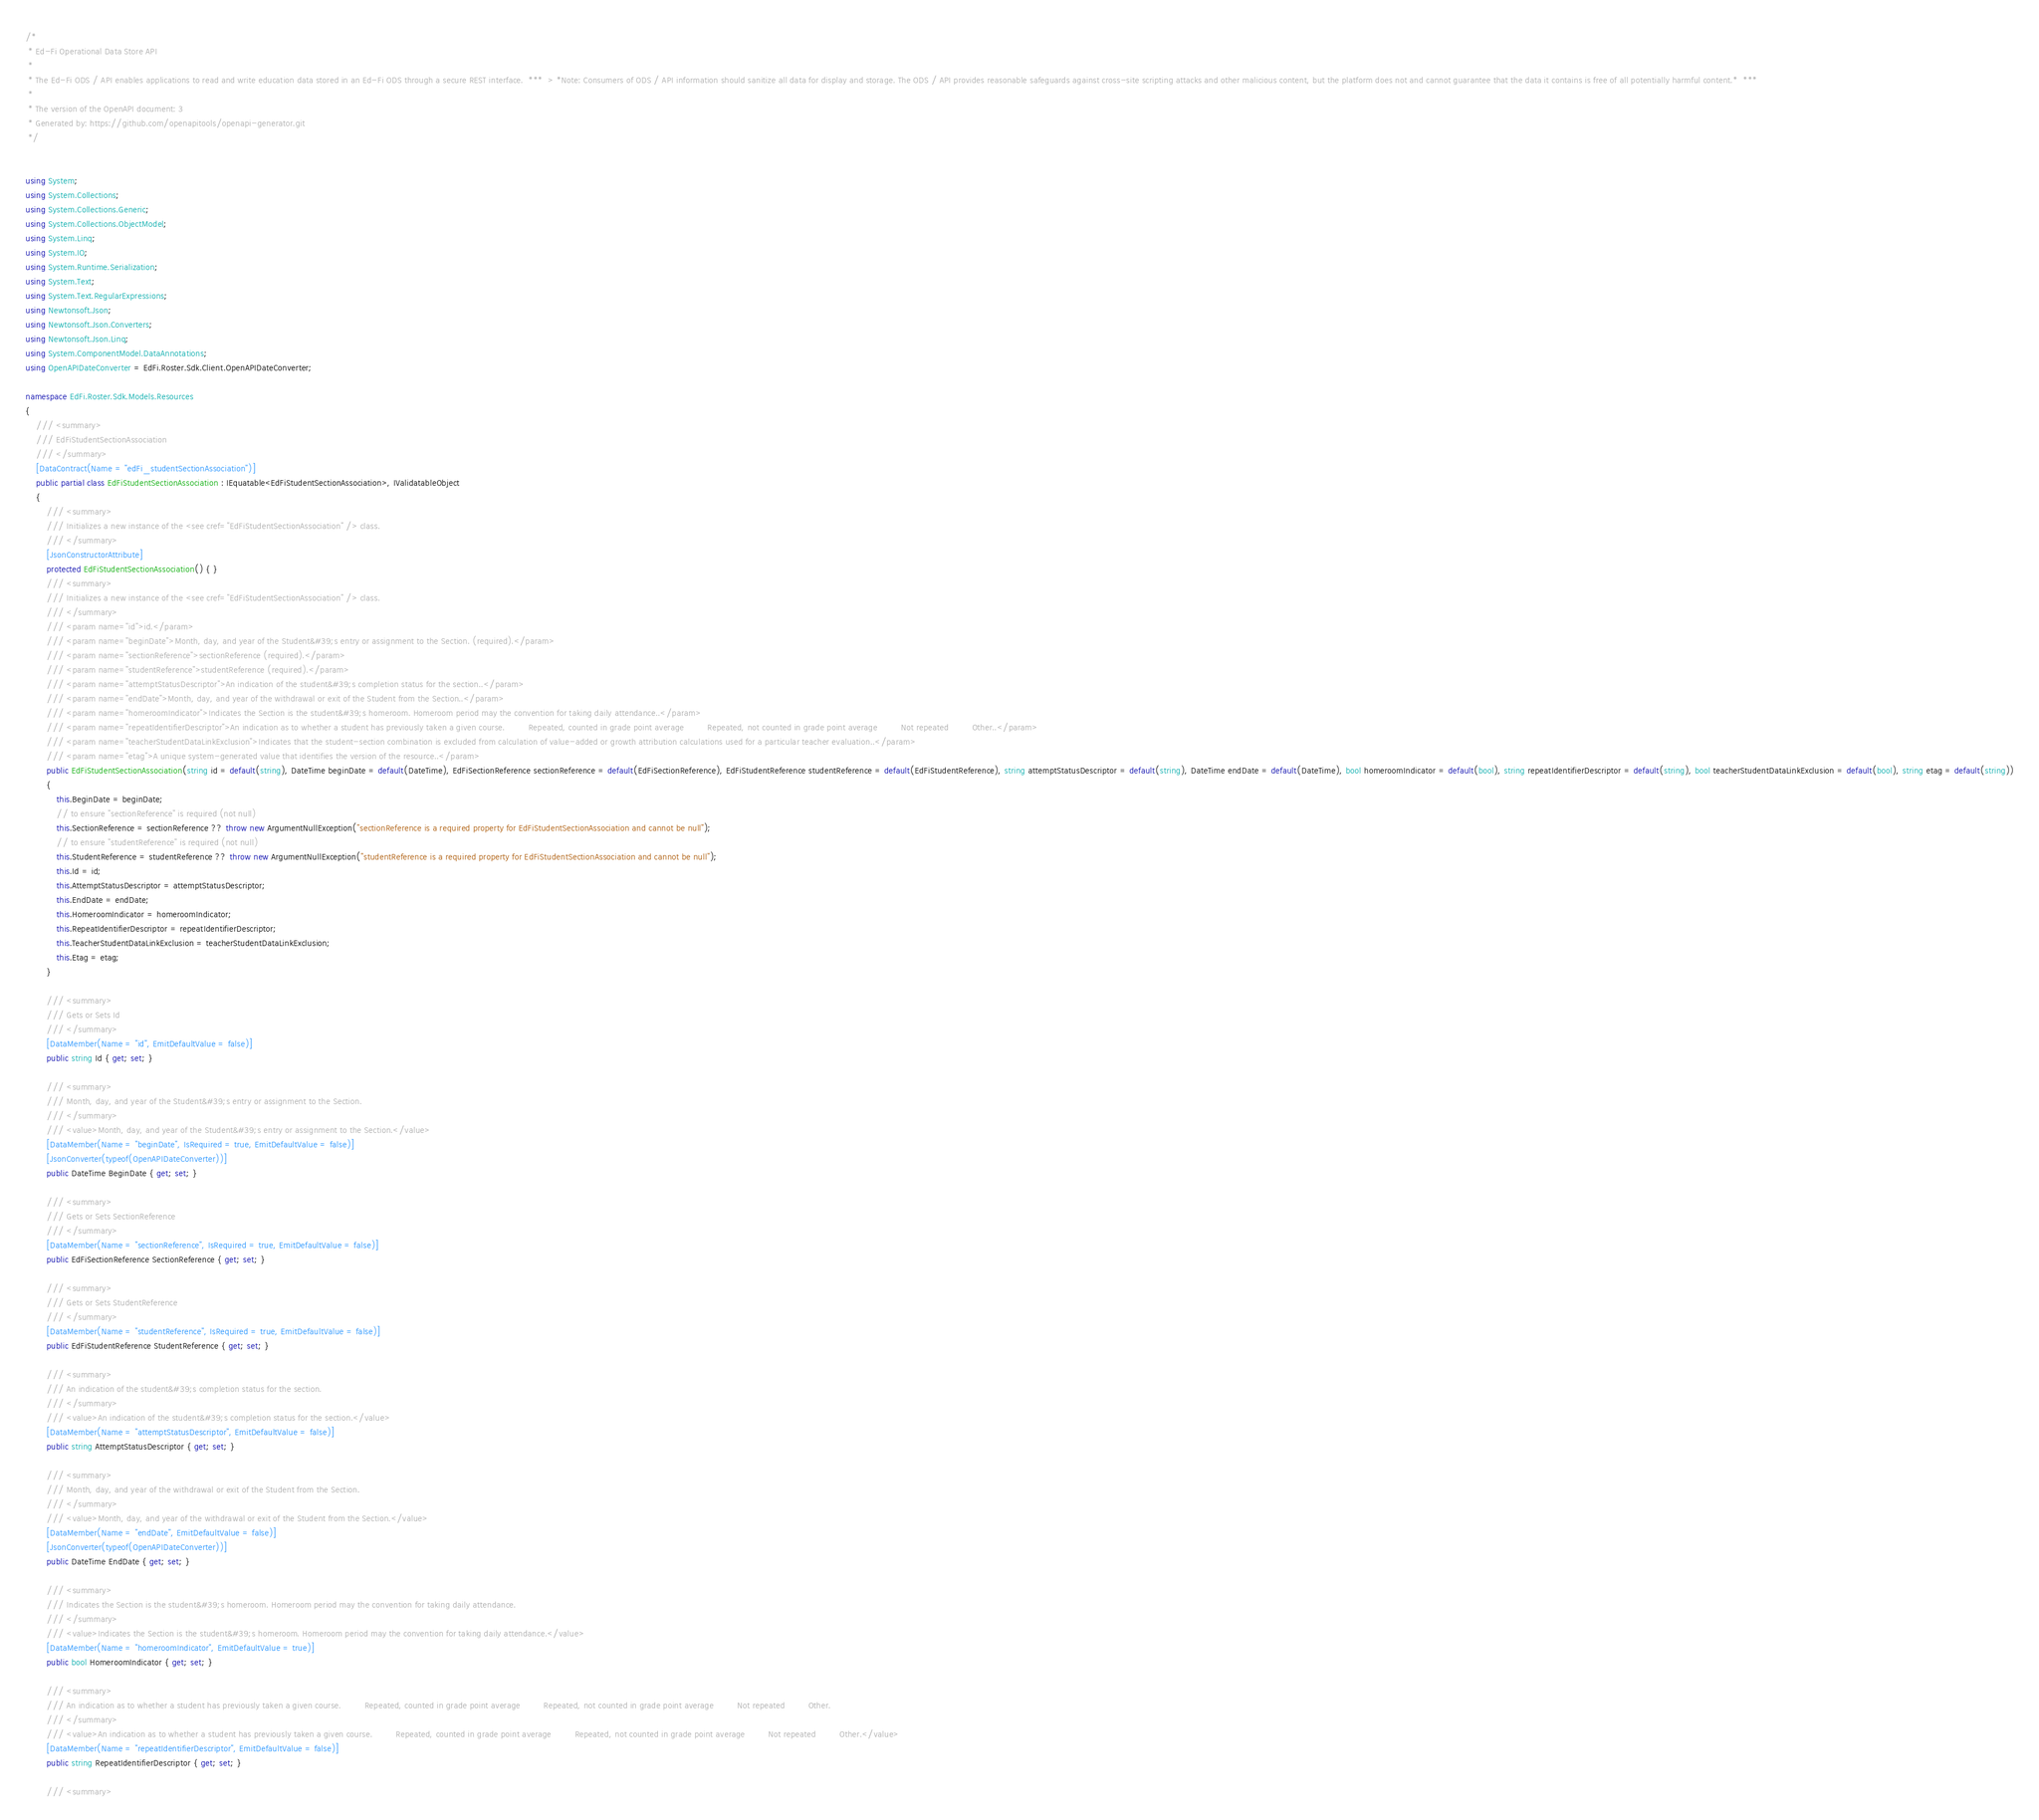<code> <loc_0><loc_0><loc_500><loc_500><_C#_>/*
 * Ed-Fi Operational Data Store API
 *
 * The Ed-Fi ODS / API enables applications to read and write education data stored in an Ed-Fi ODS through a secure REST interface.  ***  > *Note: Consumers of ODS / API information should sanitize all data for display and storage. The ODS / API provides reasonable safeguards against cross-site scripting attacks and other malicious content, but the platform does not and cannot guarantee that the data it contains is free of all potentially harmful content.*  *** 
 *
 * The version of the OpenAPI document: 3
 * Generated by: https://github.com/openapitools/openapi-generator.git
 */


using System;
using System.Collections;
using System.Collections.Generic;
using System.Collections.ObjectModel;
using System.Linq;
using System.IO;
using System.Runtime.Serialization;
using System.Text;
using System.Text.RegularExpressions;
using Newtonsoft.Json;
using Newtonsoft.Json.Converters;
using Newtonsoft.Json.Linq;
using System.ComponentModel.DataAnnotations;
using OpenAPIDateConverter = EdFi.Roster.Sdk.Client.OpenAPIDateConverter;

namespace EdFi.Roster.Sdk.Models.Resources
{
    /// <summary>
    /// EdFiStudentSectionAssociation
    /// </summary>
    [DataContract(Name = "edFi_studentSectionAssociation")]
    public partial class EdFiStudentSectionAssociation : IEquatable<EdFiStudentSectionAssociation>, IValidatableObject
    {
        /// <summary>
        /// Initializes a new instance of the <see cref="EdFiStudentSectionAssociation" /> class.
        /// </summary>
        [JsonConstructorAttribute]
        protected EdFiStudentSectionAssociation() { }
        /// <summary>
        /// Initializes a new instance of the <see cref="EdFiStudentSectionAssociation" /> class.
        /// </summary>
        /// <param name="id">id.</param>
        /// <param name="beginDate">Month, day, and year of the Student&#39;s entry or assignment to the Section. (required).</param>
        /// <param name="sectionReference">sectionReference (required).</param>
        /// <param name="studentReference">studentReference (required).</param>
        /// <param name="attemptStatusDescriptor">An indication of the student&#39;s completion status for the section..</param>
        /// <param name="endDate">Month, day, and year of the withdrawal or exit of the Student from the Section..</param>
        /// <param name="homeroomIndicator">Indicates the Section is the student&#39;s homeroom. Homeroom period may the convention for taking daily attendance..</param>
        /// <param name="repeatIdentifierDescriptor">An indication as to whether a student has previously taken a given course.         Repeated, counted in grade point average         Repeated, not counted in grade point average         Not repeated         Other..</param>
        /// <param name="teacherStudentDataLinkExclusion">Indicates that the student-section combination is excluded from calculation of value-added or growth attribution calculations used for a particular teacher evaluation..</param>
        /// <param name="etag">A unique system-generated value that identifies the version of the resource..</param>
        public EdFiStudentSectionAssociation(string id = default(string), DateTime beginDate = default(DateTime), EdFiSectionReference sectionReference = default(EdFiSectionReference), EdFiStudentReference studentReference = default(EdFiStudentReference), string attemptStatusDescriptor = default(string), DateTime endDate = default(DateTime), bool homeroomIndicator = default(bool), string repeatIdentifierDescriptor = default(string), bool teacherStudentDataLinkExclusion = default(bool), string etag = default(string))
        {
            this.BeginDate = beginDate;
            // to ensure "sectionReference" is required (not null)
            this.SectionReference = sectionReference ?? throw new ArgumentNullException("sectionReference is a required property for EdFiStudentSectionAssociation and cannot be null");
            // to ensure "studentReference" is required (not null)
            this.StudentReference = studentReference ?? throw new ArgumentNullException("studentReference is a required property for EdFiStudentSectionAssociation and cannot be null");
            this.Id = id;
            this.AttemptStatusDescriptor = attemptStatusDescriptor;
            this.EndDate = endDate;
            this.HomeroomIndicator = homeroomIndicator;
            this.RepeatIdentifierDescriptor = repeatIdentifierDescriptor;
            this.TeacherStudentDataLinkExclusion = teacherStudentDataLinkExclusion;
            this.Etag = etag;
        }

        /// <summary>
        /// Gets or Sets Id
        /// </summary>
        [DataMember(Name = "id", EmitDefaultValue = false)]
        public string Id { get; set; }

        /// <summary>
        /// Month, day, and year of the Student&#39;s entry or assignment to the Section.
        /// </summary>
        /// <value>Month, day, and year of the Student&#39;s entry or assignment to the Section.</value>
        [DataMember(Name = "beginDate", IsRequired = true, EmitDefaultValue = false)]
        [JsonConverter(typeof(OpenAPIDateConverter))]
        public DateTime BeginDate { get; set; }

        /// <summary>
        /// Gets or Sets SectionReference
        /// </summary>
        [DataMember(Name = "sectionReference", IsRequired = true, EmitDefaultValue = false)]
        public EdFiSectionReference SectionReference { get; set; }

        /// <summary>
        /// Gets or Sets StudentReference
        /// </summary>
        [DataMember(Name = "studentReference", IsRequired = true, EmitDefaultValue = false)]
        public EdFiStudentReference StudentReference { get; set; }

        /// <summary>
        /// An indication of the student&#39;s completion status for the section.
        /// </summary>
        /// <value>An indication of the student&#39;s completion status for the section.</value>
        [DataMember(Name = "attemptStatusDescriptor", EmitDefaultValue = false)]
        public string AttemptStatusDescriptor { get; set; }

        /// <summary>
        /// Month, day, and year of the withdrawal or exit of the Student from the Section.
        /// </summary>
        /// <value>Month, day, and year of the withdrawal or exit of the Student from the Section.</value>
        [DataMember(Name = "endDate", EmitDefaultValue = false)]
        [JsonConverter(typeof(OpenAPIDateConverter))]
        public DateTime EndDate { get; set; }

        /// <summary>
        /// Indicates the Section is the student&#39;s homeroom. Homeroom period may the convention for taking daily attendance.
        /// </summary>
        /// <value>Indicates the Section is the student&#39;s homeroom. Homeroom period may the convention for taking daily attendance.</value>
        [DataMember(Name = "homeroomIndicator", EmitDefaultValue = true)]
        public bool HomeroomIndicator { get; set; }

        /// <summary>
        /// An indication as to whether a student has previously taken a given course.         Repeated, counted in grade point average         Repeated, not counted in grade point average         Not repeated         Other.
        /// </summary>
        /// <value>An indication as to whether a student has previously taken a given course.         Repeated, counted in grade point average         Repeated, not counted in grade point average         Not repeated         Other.</value>
        [DataMember(Name = "repeatIdentifierDescriptor", EmitDefaultValue = false)]
        public string RepeatIdentifierDescriptor { get; set; }

        /// <summary></code> 